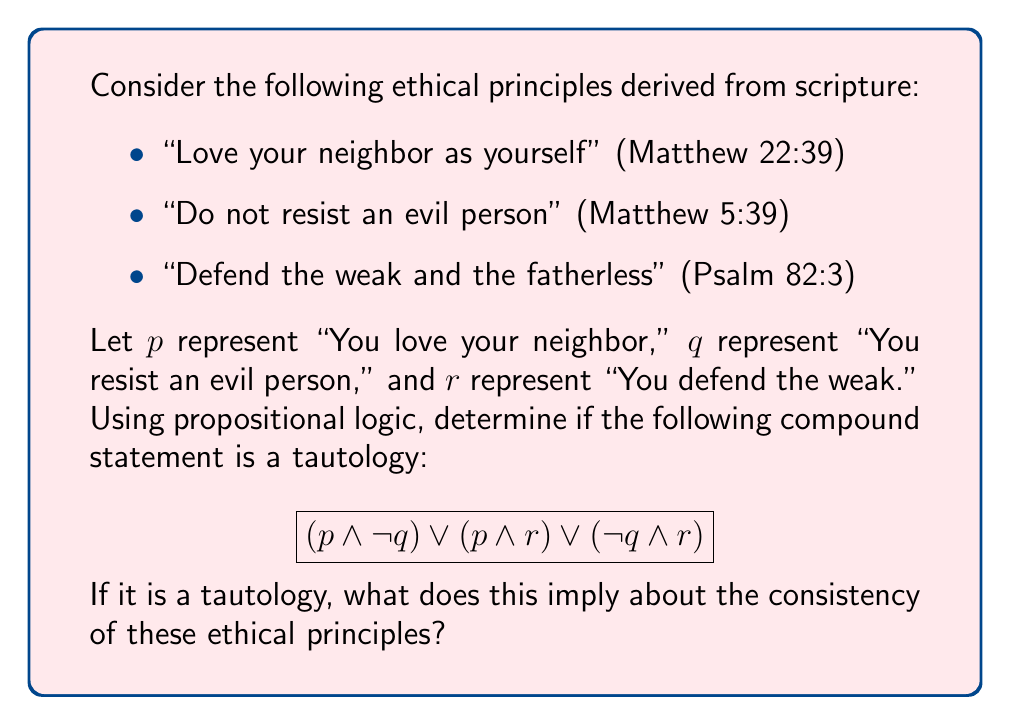What is the answer to this math problem? To determine if the compound statement is a tautology, we'll use a truth table to evaluate all possible combinations of truth values for $p$, $q$, and $r$.

1. First, let's construct the truth table:

   $$\begin{array}{cccc|ccc|c}
   p & q & r & | & p \land \lnot q & p \land r & \lnot q \land r & (p \land \lnot q) \lor (p \land r) \lor (\lnot q \land r) \\
   \hline
   T & T & T & | & F & T & F & T \\
   T & T & F & | & F & F & F & F \\
   T & F & T & | & T & T & T & T \\
   T & F & F & | & T & F & F & T \\
   F & T & T & | & F & F & T & T \\
   F & T & F & | & F & F & F & F \\
   F & F & T & | & F & F & T & T \\
   F & F & F & | & F & F & F & F \\
   \end{array}$$

2. Analyze the final column of the truth table:
   We see that the compound statement is true in 5 out of 8 cases, but not in all cases. Therefore, it is not a tautology.

3. Interpretation in the context of ethical principles:
   - The compound statement being false in some cases suggests that these ethical principles are not always mutually consistent.
   - For example, when $p$ is false (not loving your neighbor), $q$ is true (resisting an evil person), and $r$ is false (not defending the weak), all three individual principles are violated simultaneously.
   - This result aligns with the complexity of real-world ethical dilemmas, where scriptural principles may sometimes appear to be in tension with one another.

4. Theological reflection:
   As a pastor, we might interpret this result as a reminder of the importance of wisdom and discernment in applying scriptural principles. It highlights the need for careful consideration of context and the guidance of the Holy Spirit when navigating complex ethical situations.
Answer: Not a tautology; ethical principles not always mutually consistent. 